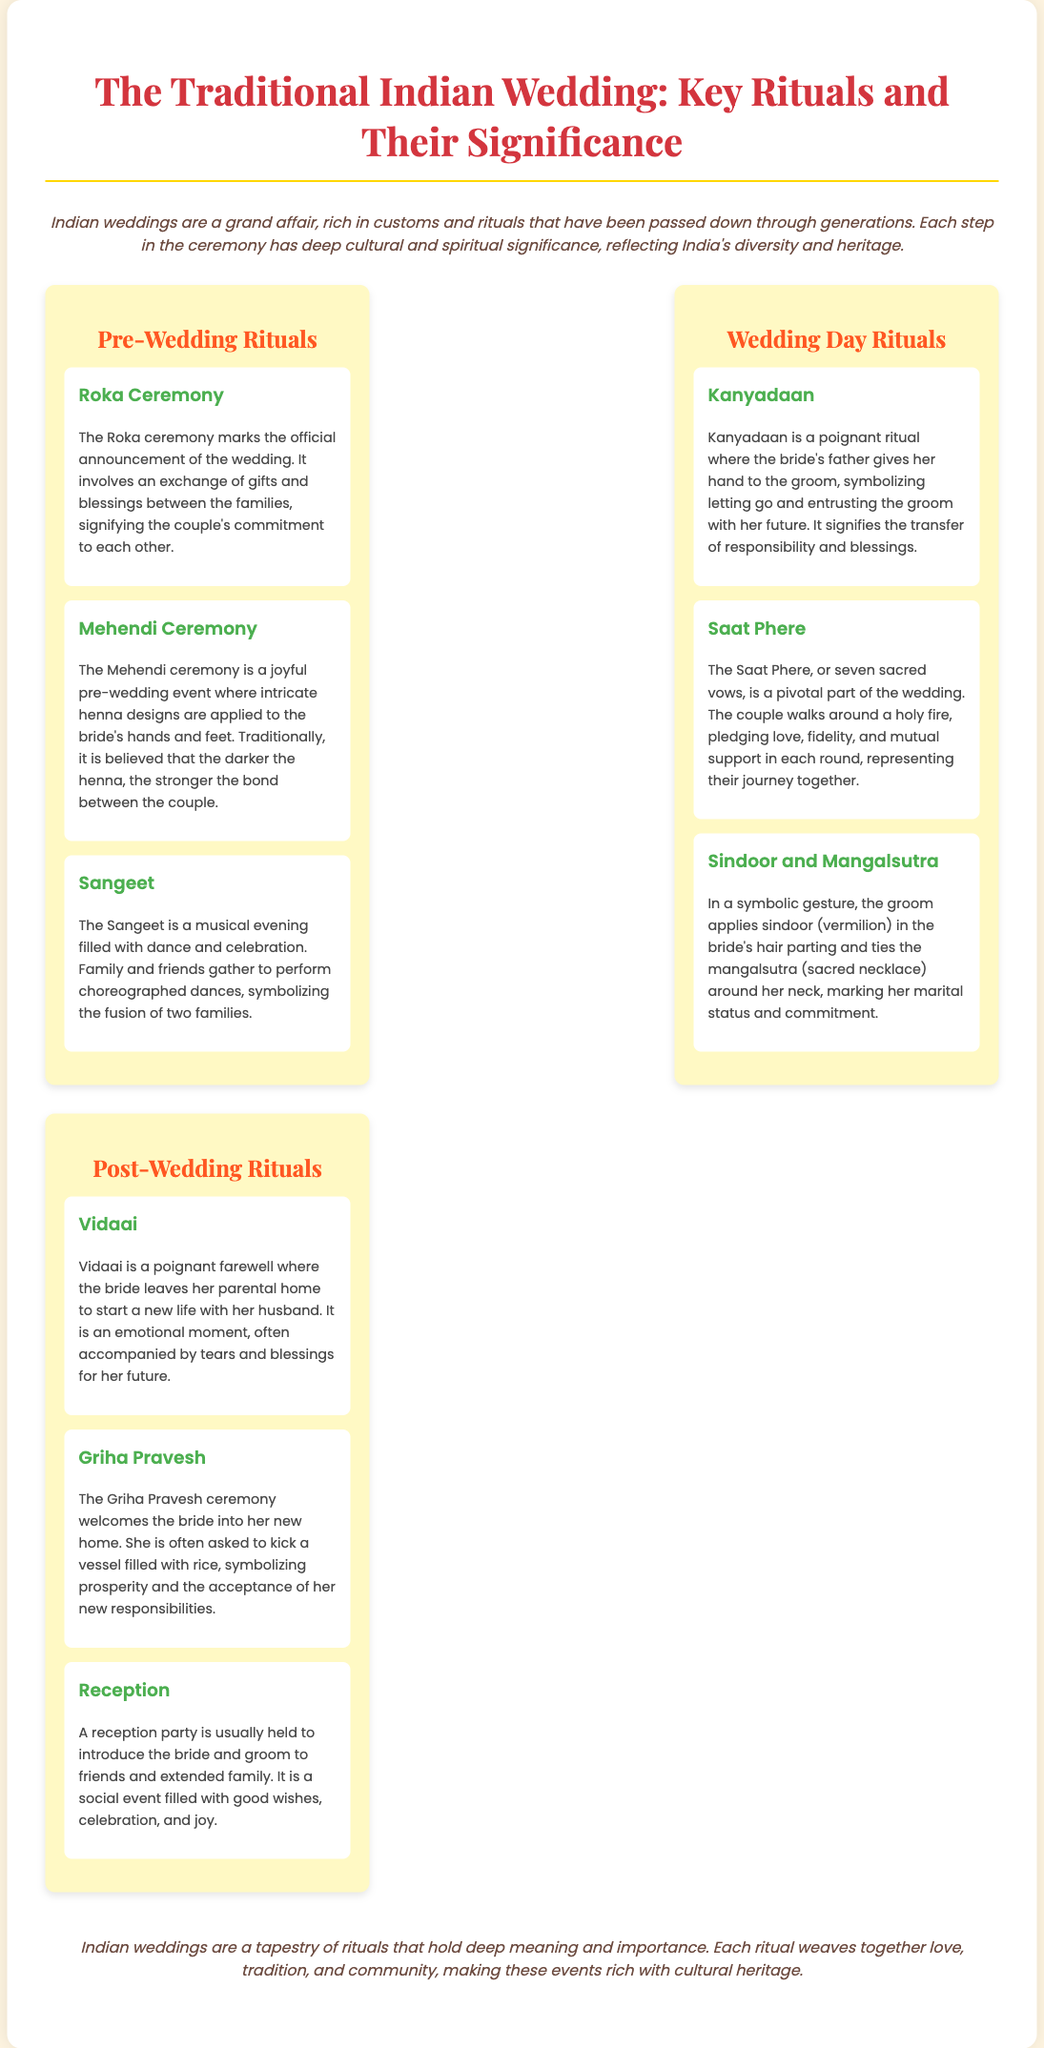What is the Roka Ceremony? The Roka ceremony marks the official announcement of the wedding and involves an exchange of gifts and blessings between the families.
Answer: Official announcement What does the Mehendi ceremony symbolize? The Mehendi ceremony is believed to signify that the darker the henna, the stronger the bond between the couple.
Answer: Stronger bond What is Kanyadaan? Kanyadaan is a ritual where the bride's father gives her hand to the groom, symbolizing letting go and entrusting the groom with her future.
Answer: Letting go How many vows are exchanged in the Saat Phere? The Saat Phere involves seven sacred vows pledging love, fidelity, and mutual support.
Answer: Seven vows What happens during Vidaai? Vidaai is a farewell where the bride leaves her parental home to start a new life with her husband.
Answer: Emotional farewell What is the purpose of Griha Pravesh? Griha Pravesh welcomes the bride into her new home and symbolizes prosperity.
Answer: Welcome to new home What signifies the bride's marital status? The groom applies sindoor and ties the mangalsutra around the bride's neck.
Answer: Sindoor and mangalsutra What type of event is the Reception? The Reception is a party to introduce the bride and groom to friends and extended family.
Answer: Social event How many ritual sections are there in the document? The document describes three sections: Pre-Wedding, Wedding Day, and Post-Wedding rituals.
Answer: Three sections 